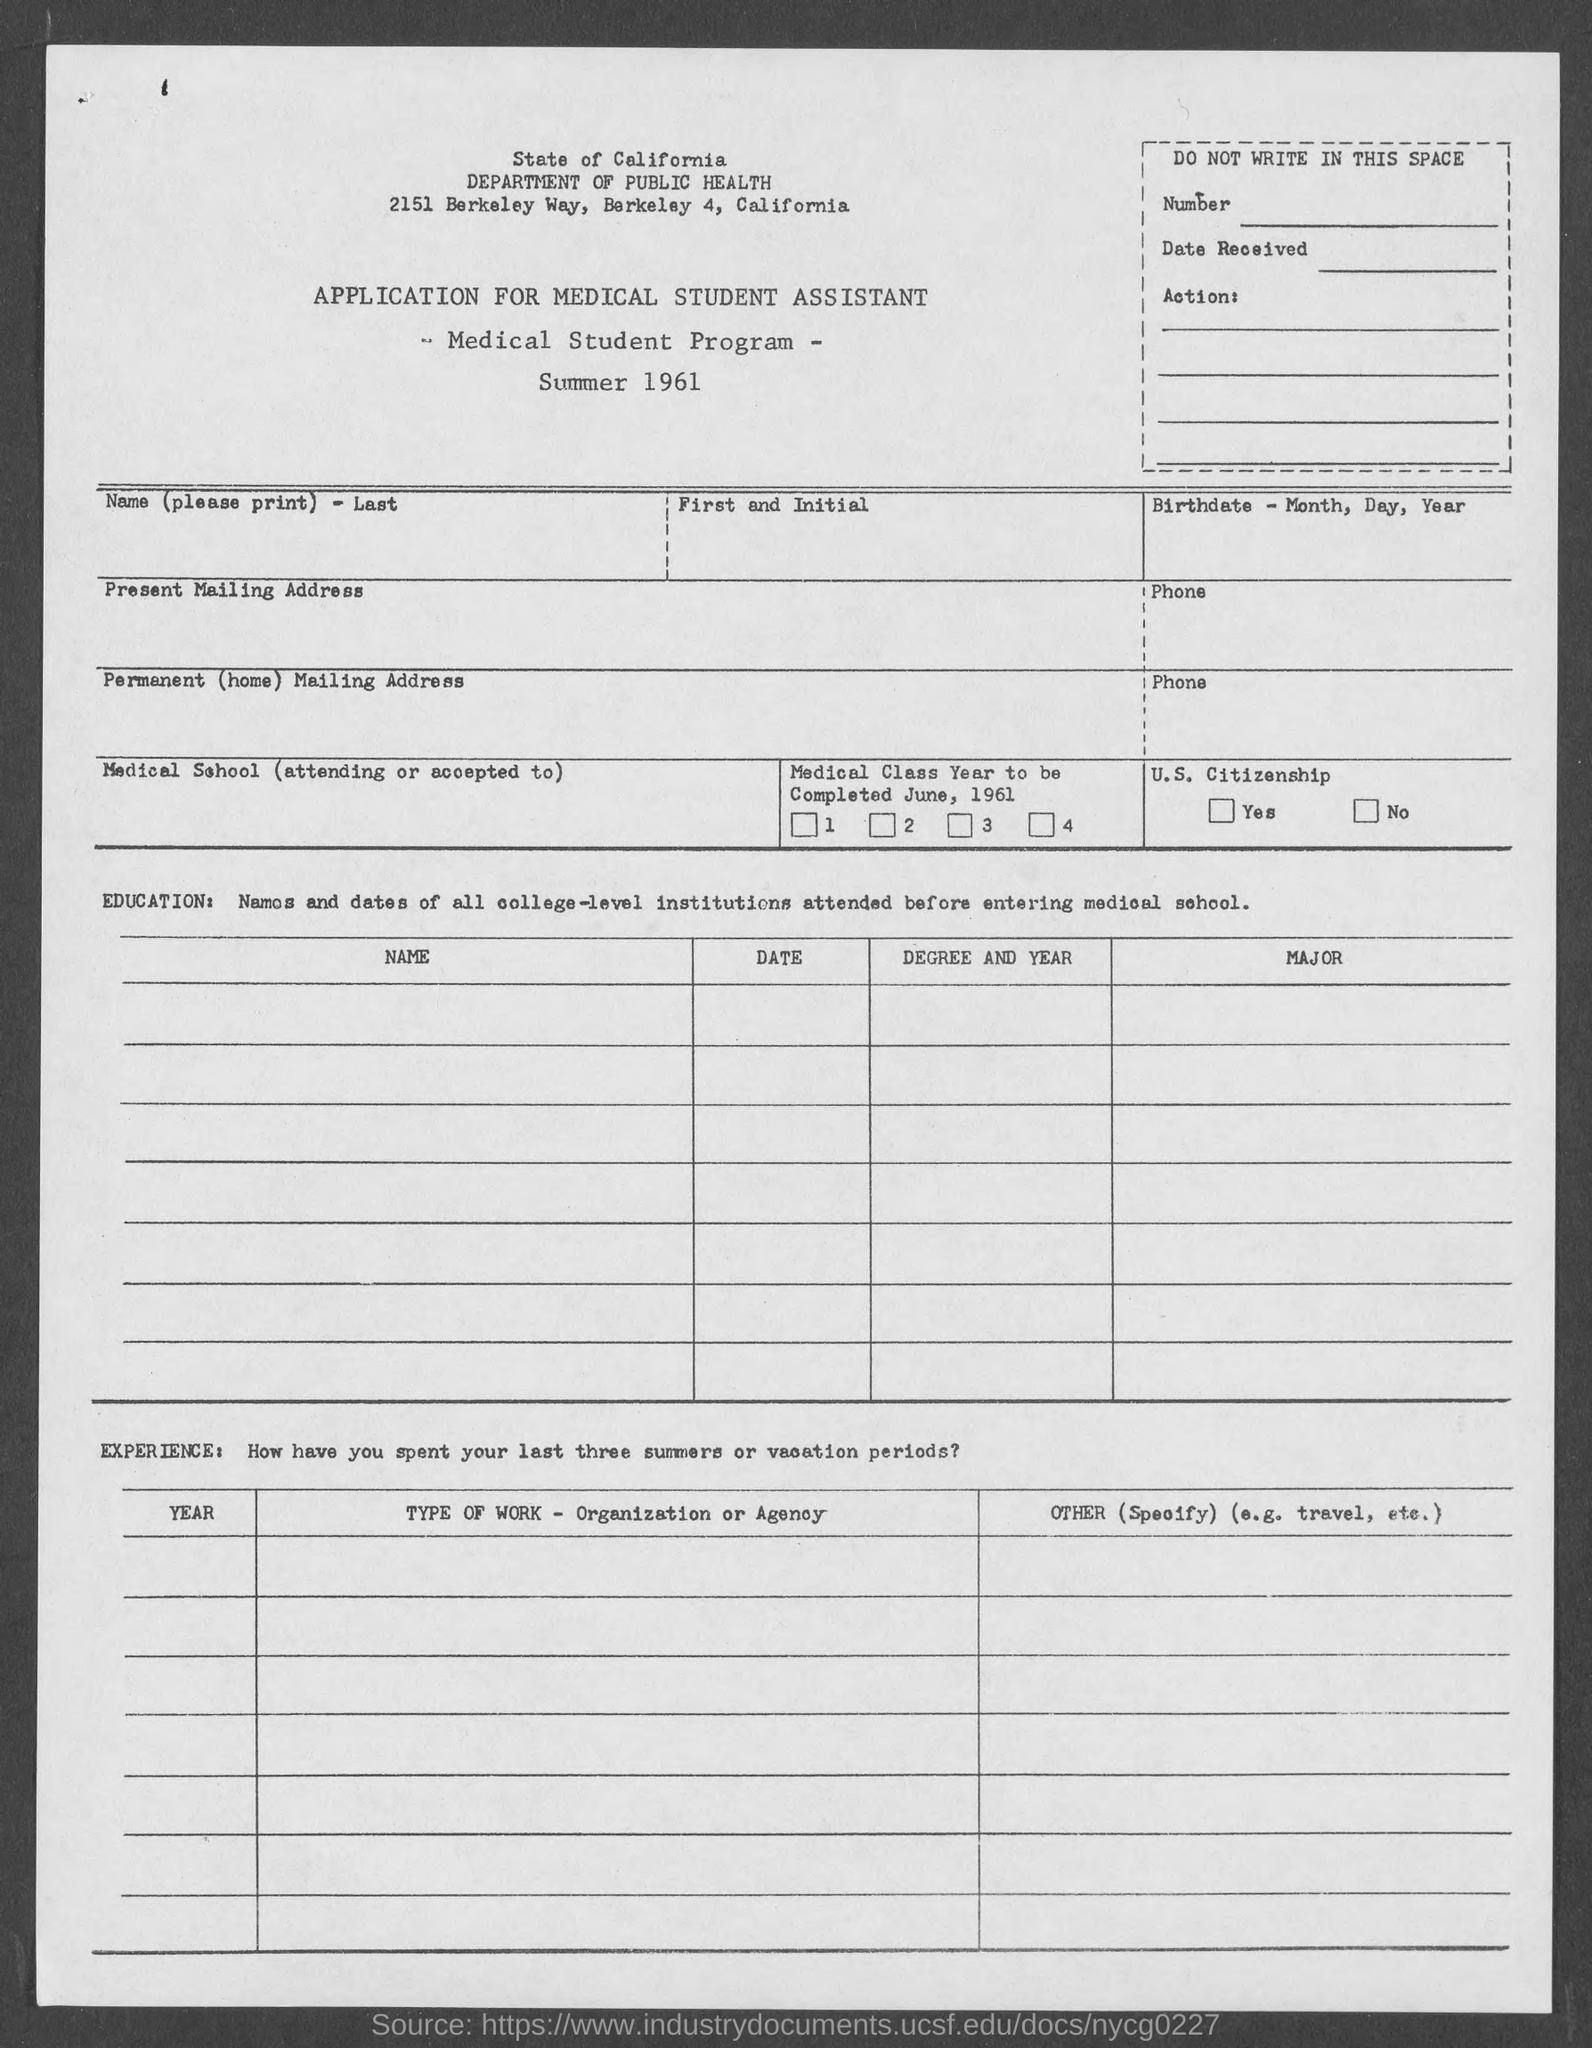Which is the department mentioned?
Provide a succinct answer. Department of Public Health. 